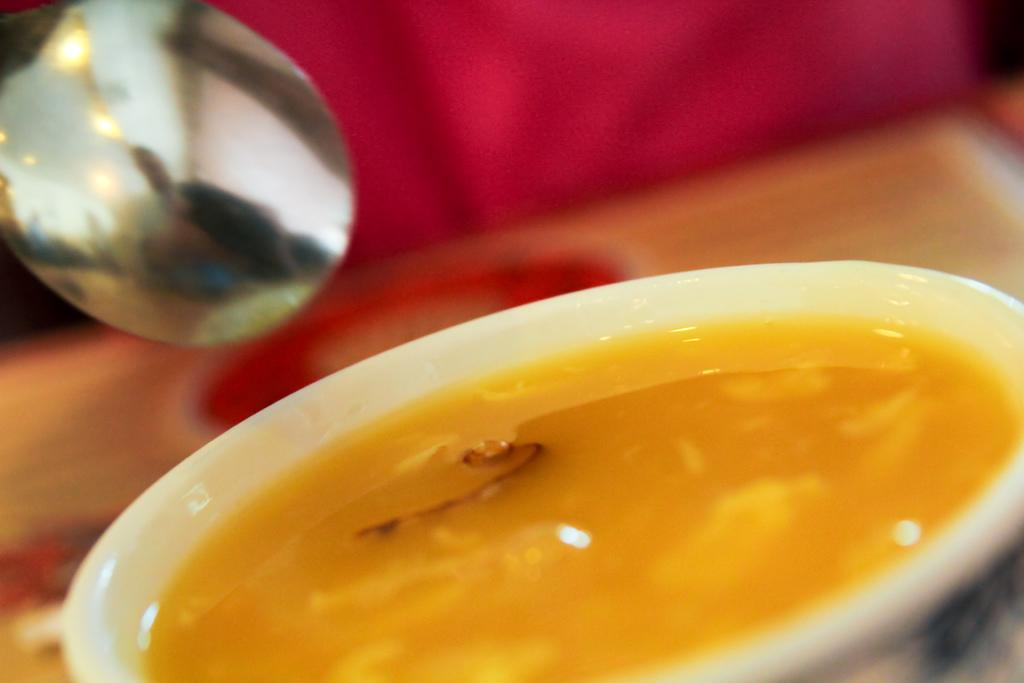What is in the bowl that is visible in the image? There is a food item in the bowl that is visible in the image. What is the bowl placed on in the image? The bowl is on a wooden surface in the image. What utensil is present in the image? There is a spoon in the image. What type of veil is draped over the food item in the image? There is no veil present in the image; the food item is not covered. 